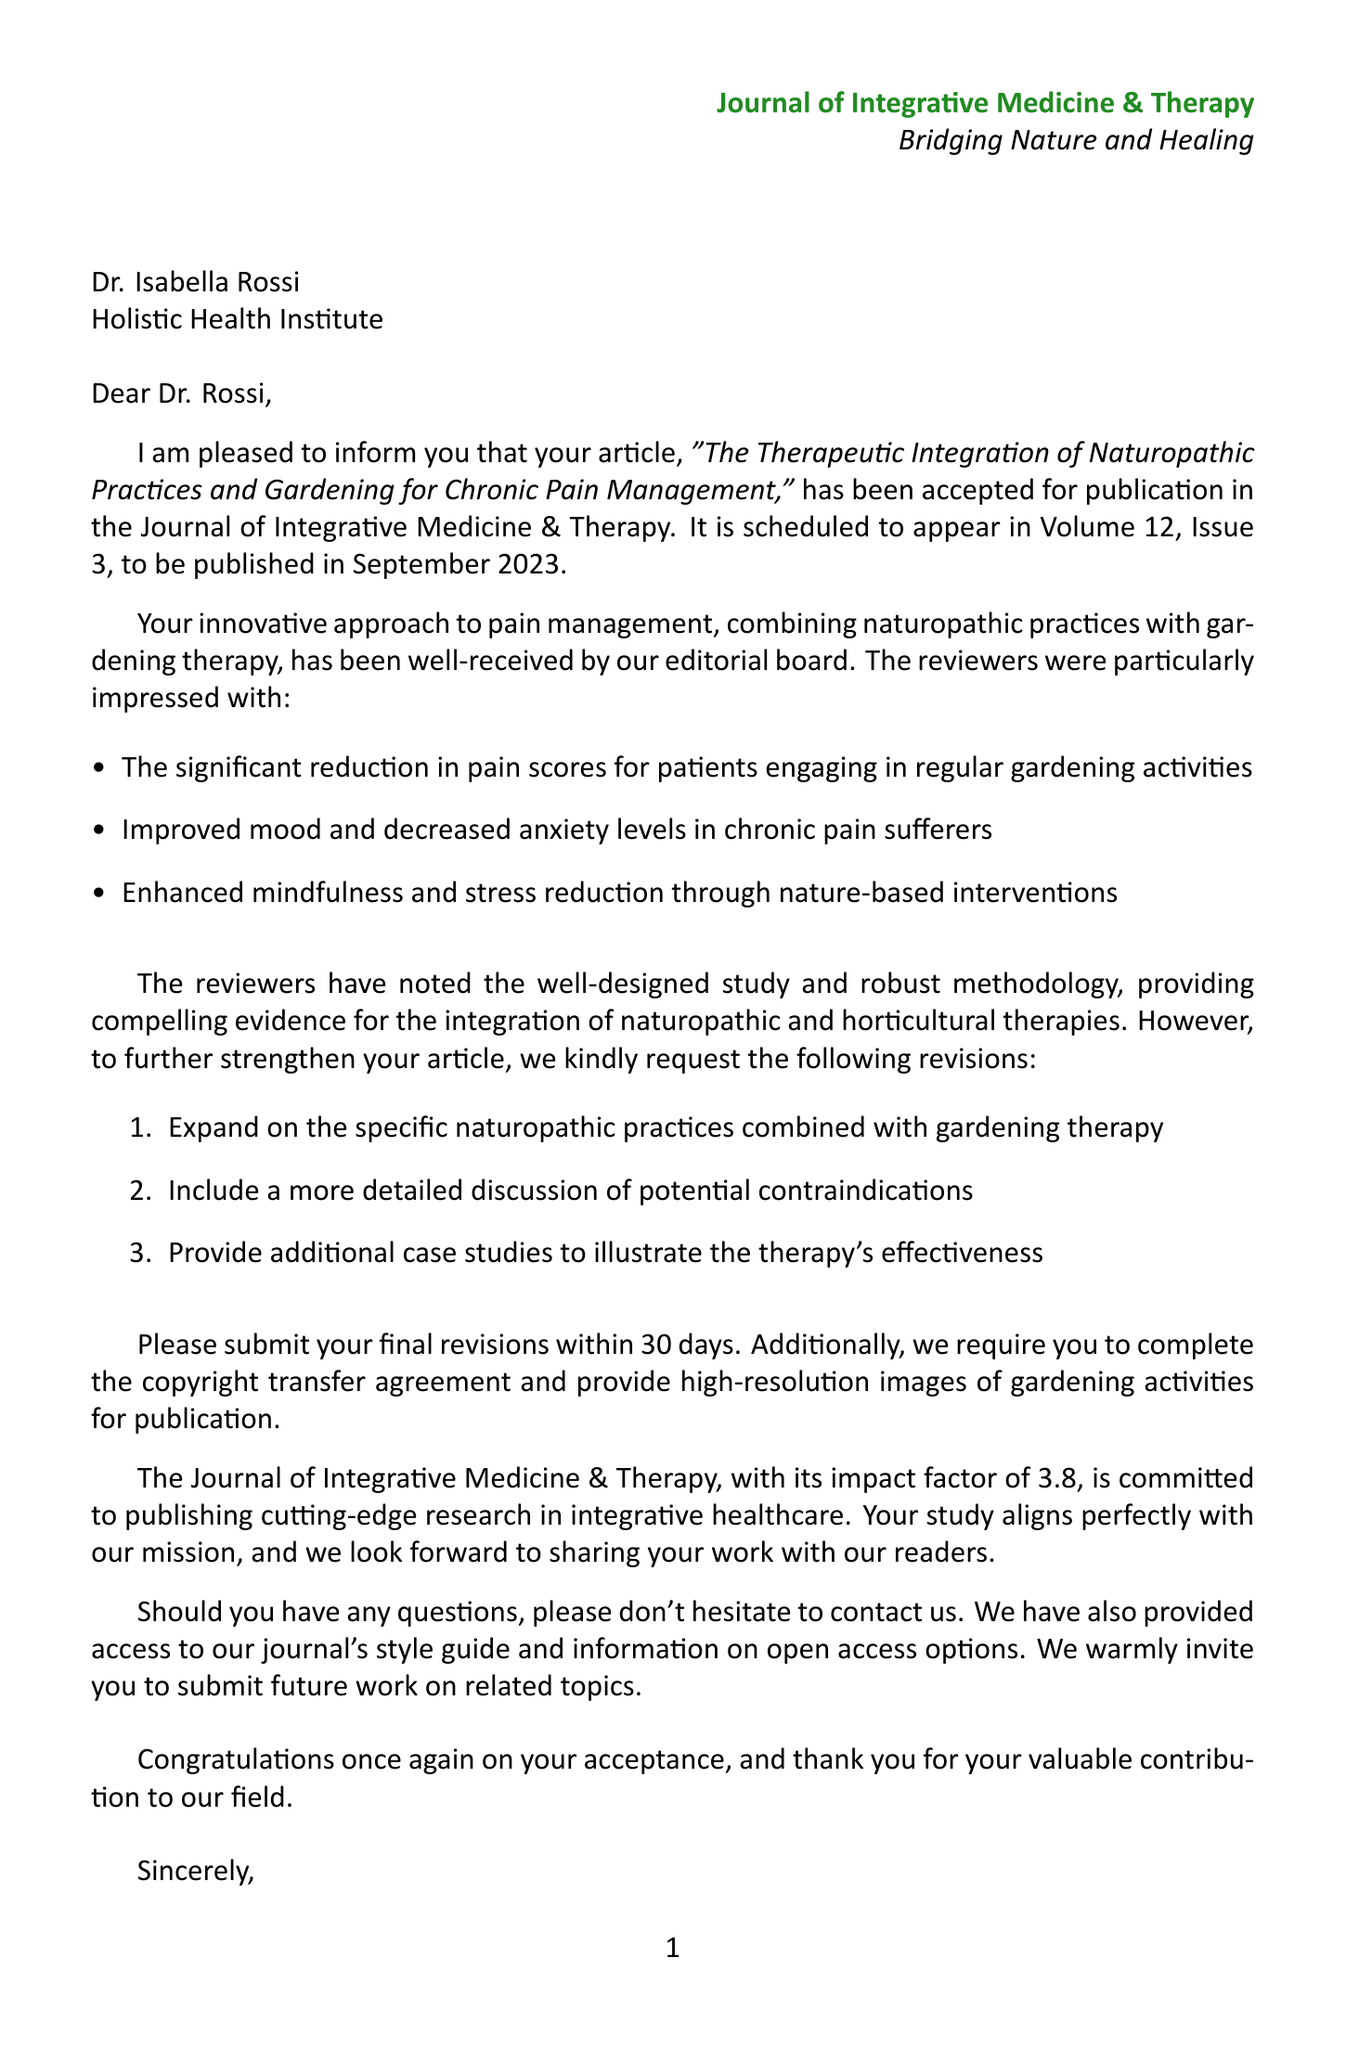What is the title of the article? The title of the article is stated in the letter as "The Therapeutic Integration of Naturopathic Practices and Gardening for Chronic Pain Management."
Answer: The Therapeutic Integration of Naturopathic Practices and Gardening for Chronic Pain Management Who is the editor of the journal? The editor of the journal, as mentioned in the document, is Dr. Sarah Greenfield.
Answer: Dr. Sarah Greenfield What is the acceptance date of the article? The acceptance date is explicitly stated in the letter as May 15, 2023.
Answer: May 15, 2023 In which volume and issue will the article be published? The volume and issue are specified as Volume 12, Issue 3.
Answer: Volume 12, Issue 3 What were some key findings of the study? One of the key findings noted in the document is the significant reduction in pain scores for patients engaging in regular gardening activities.
Answer: Significant reduction in pain scores for patients engaging in regular gardening activities What are the revision requests mentioned by the reviewers? One of the revision requests is to expand on the specific naturopathic practices combined with gardening therapy.
Answer: Expand on the specific naturopathic practices combined with gardening therapy What is the impact factor of the journal? The impact factor of the journal is provided in the letter as 3.8.
Answer: 3.8 What needs to be submitted within 30 days? The letter specifies that final revisions need to be submitted within 30 days.
Answer: Final revisions What is a required component for publication besides the revisions? Completing the copyright transfer agreement is required for publication.
Answer: Copyright transfer agreement What does the editorial board appreciate about the study? The editorial board appreciates the novel contribution to the field as mentioned in the letter.
Answer: The novel contribution to the field 